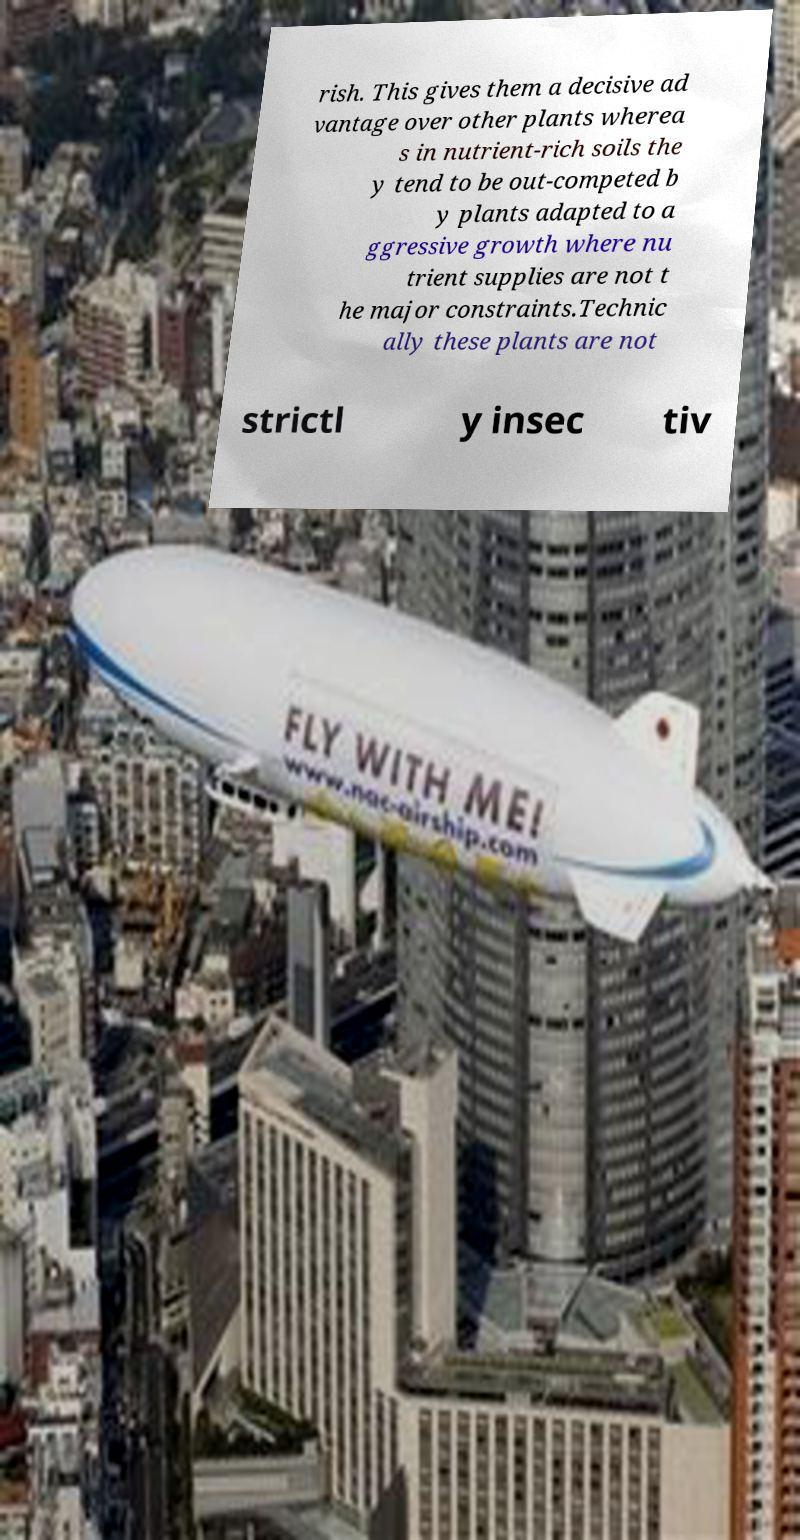For documentation purposes, I need the text within this image transcribed. Could you provide that? rish. This gives them a decisive ad vantage over other plants wherea s in nutrient-rich soils the y tend to be out-competed b y plants adapted to a ggressive growth where nu trient supplies are not t he major constraints.Technic ally these plants are not strictl y insec tiv 